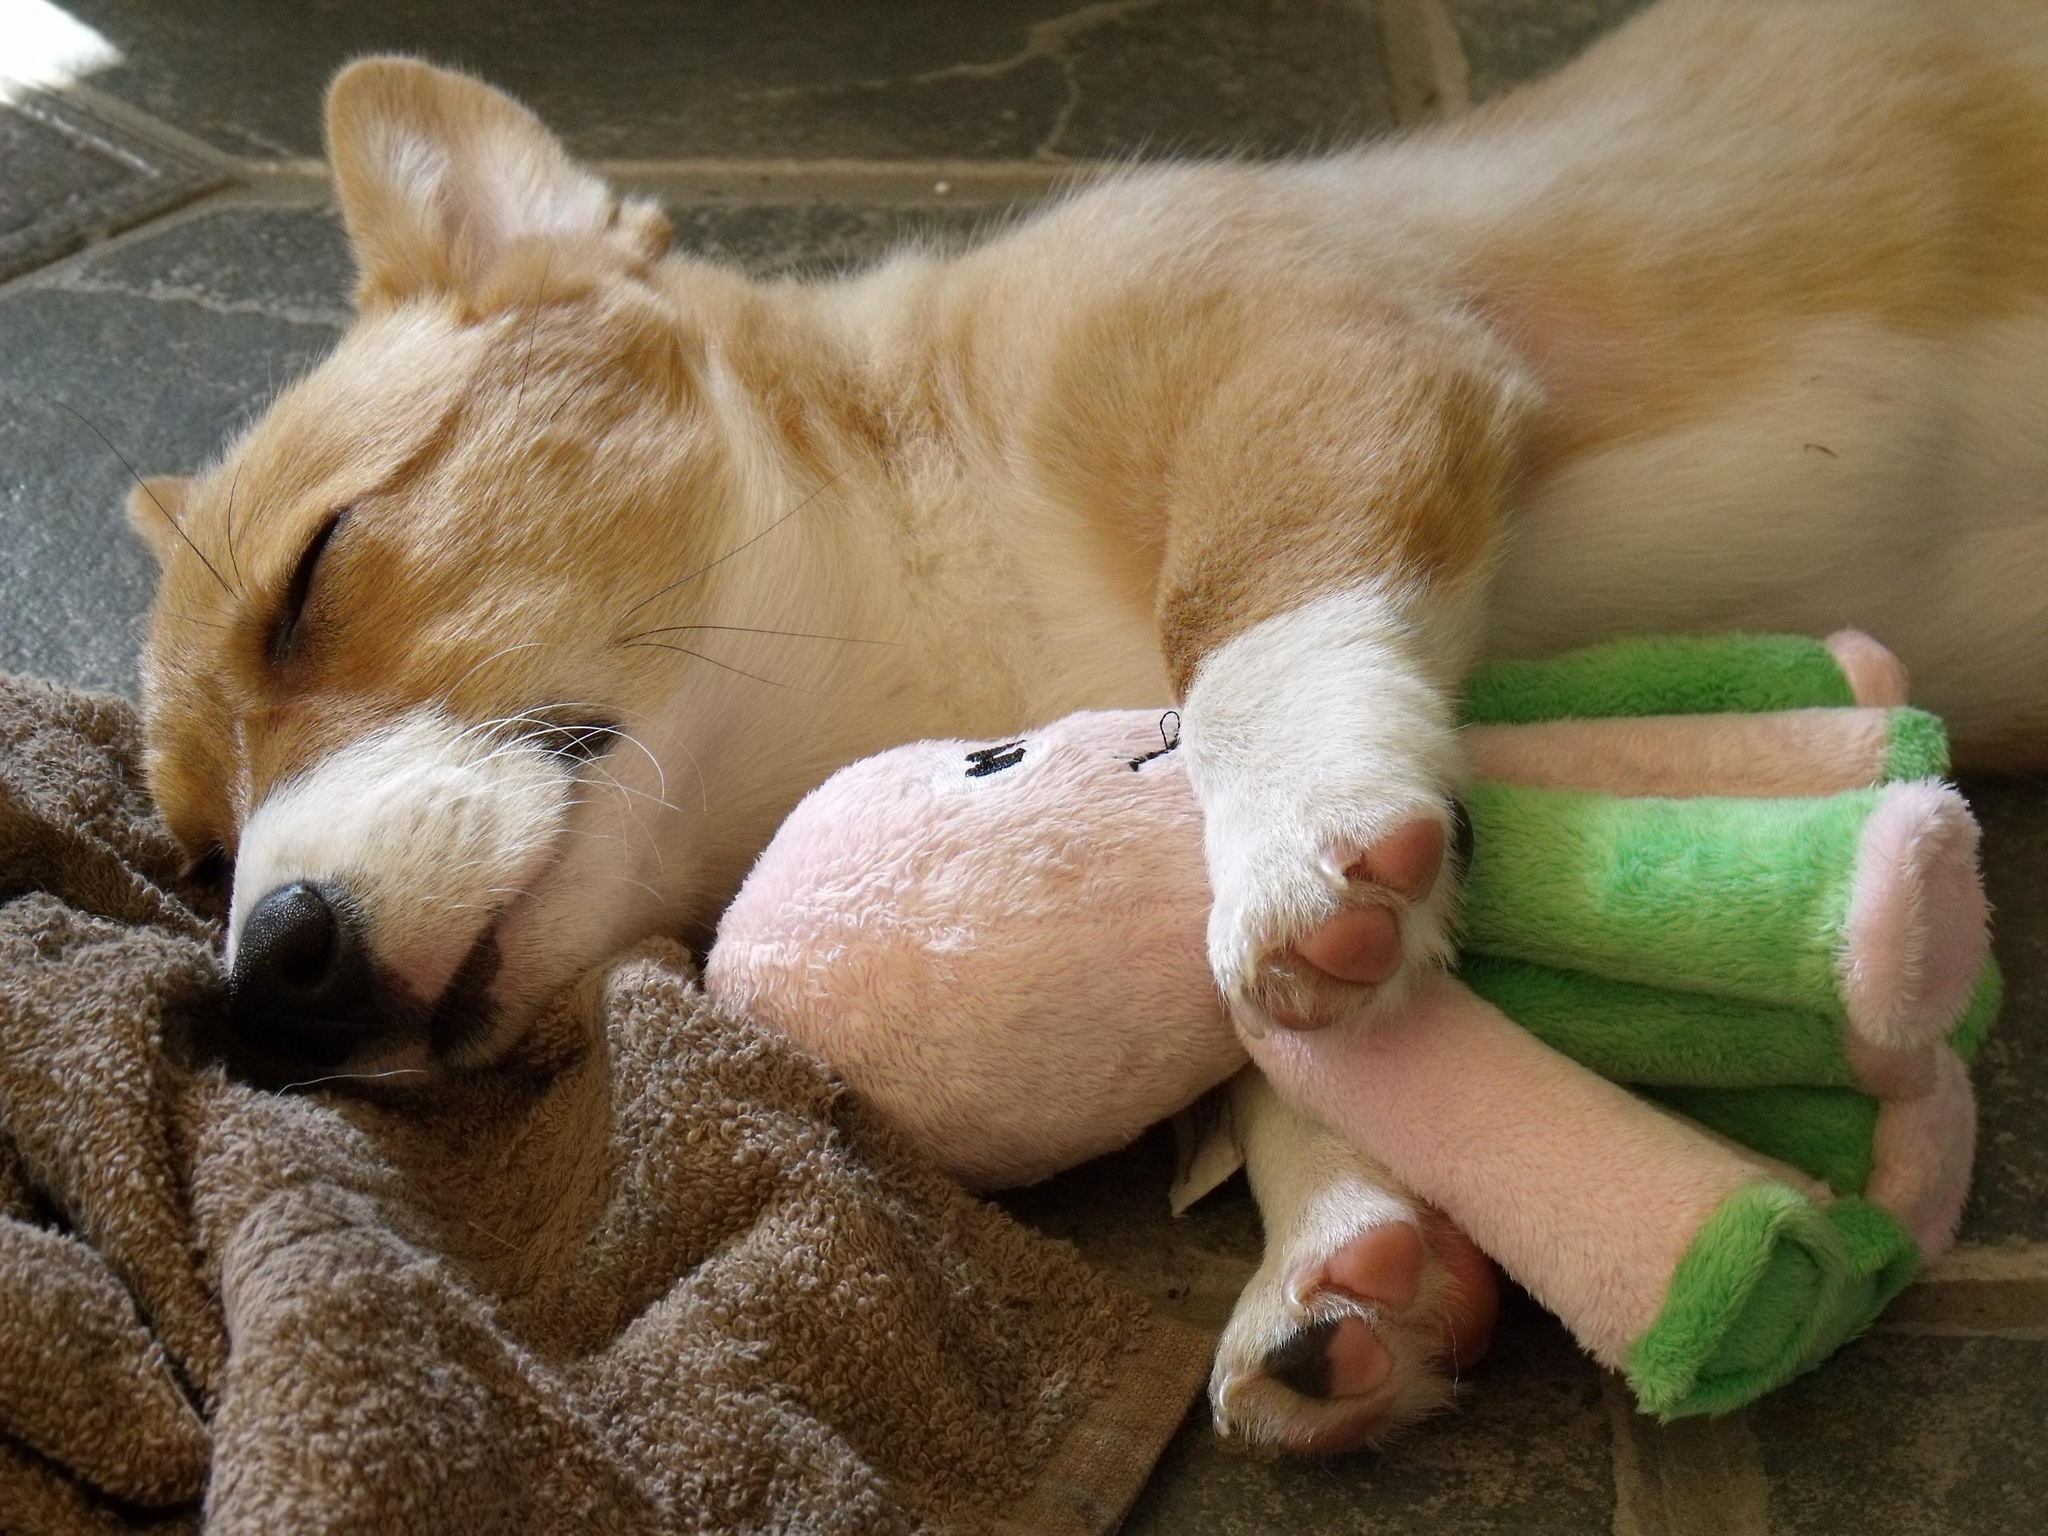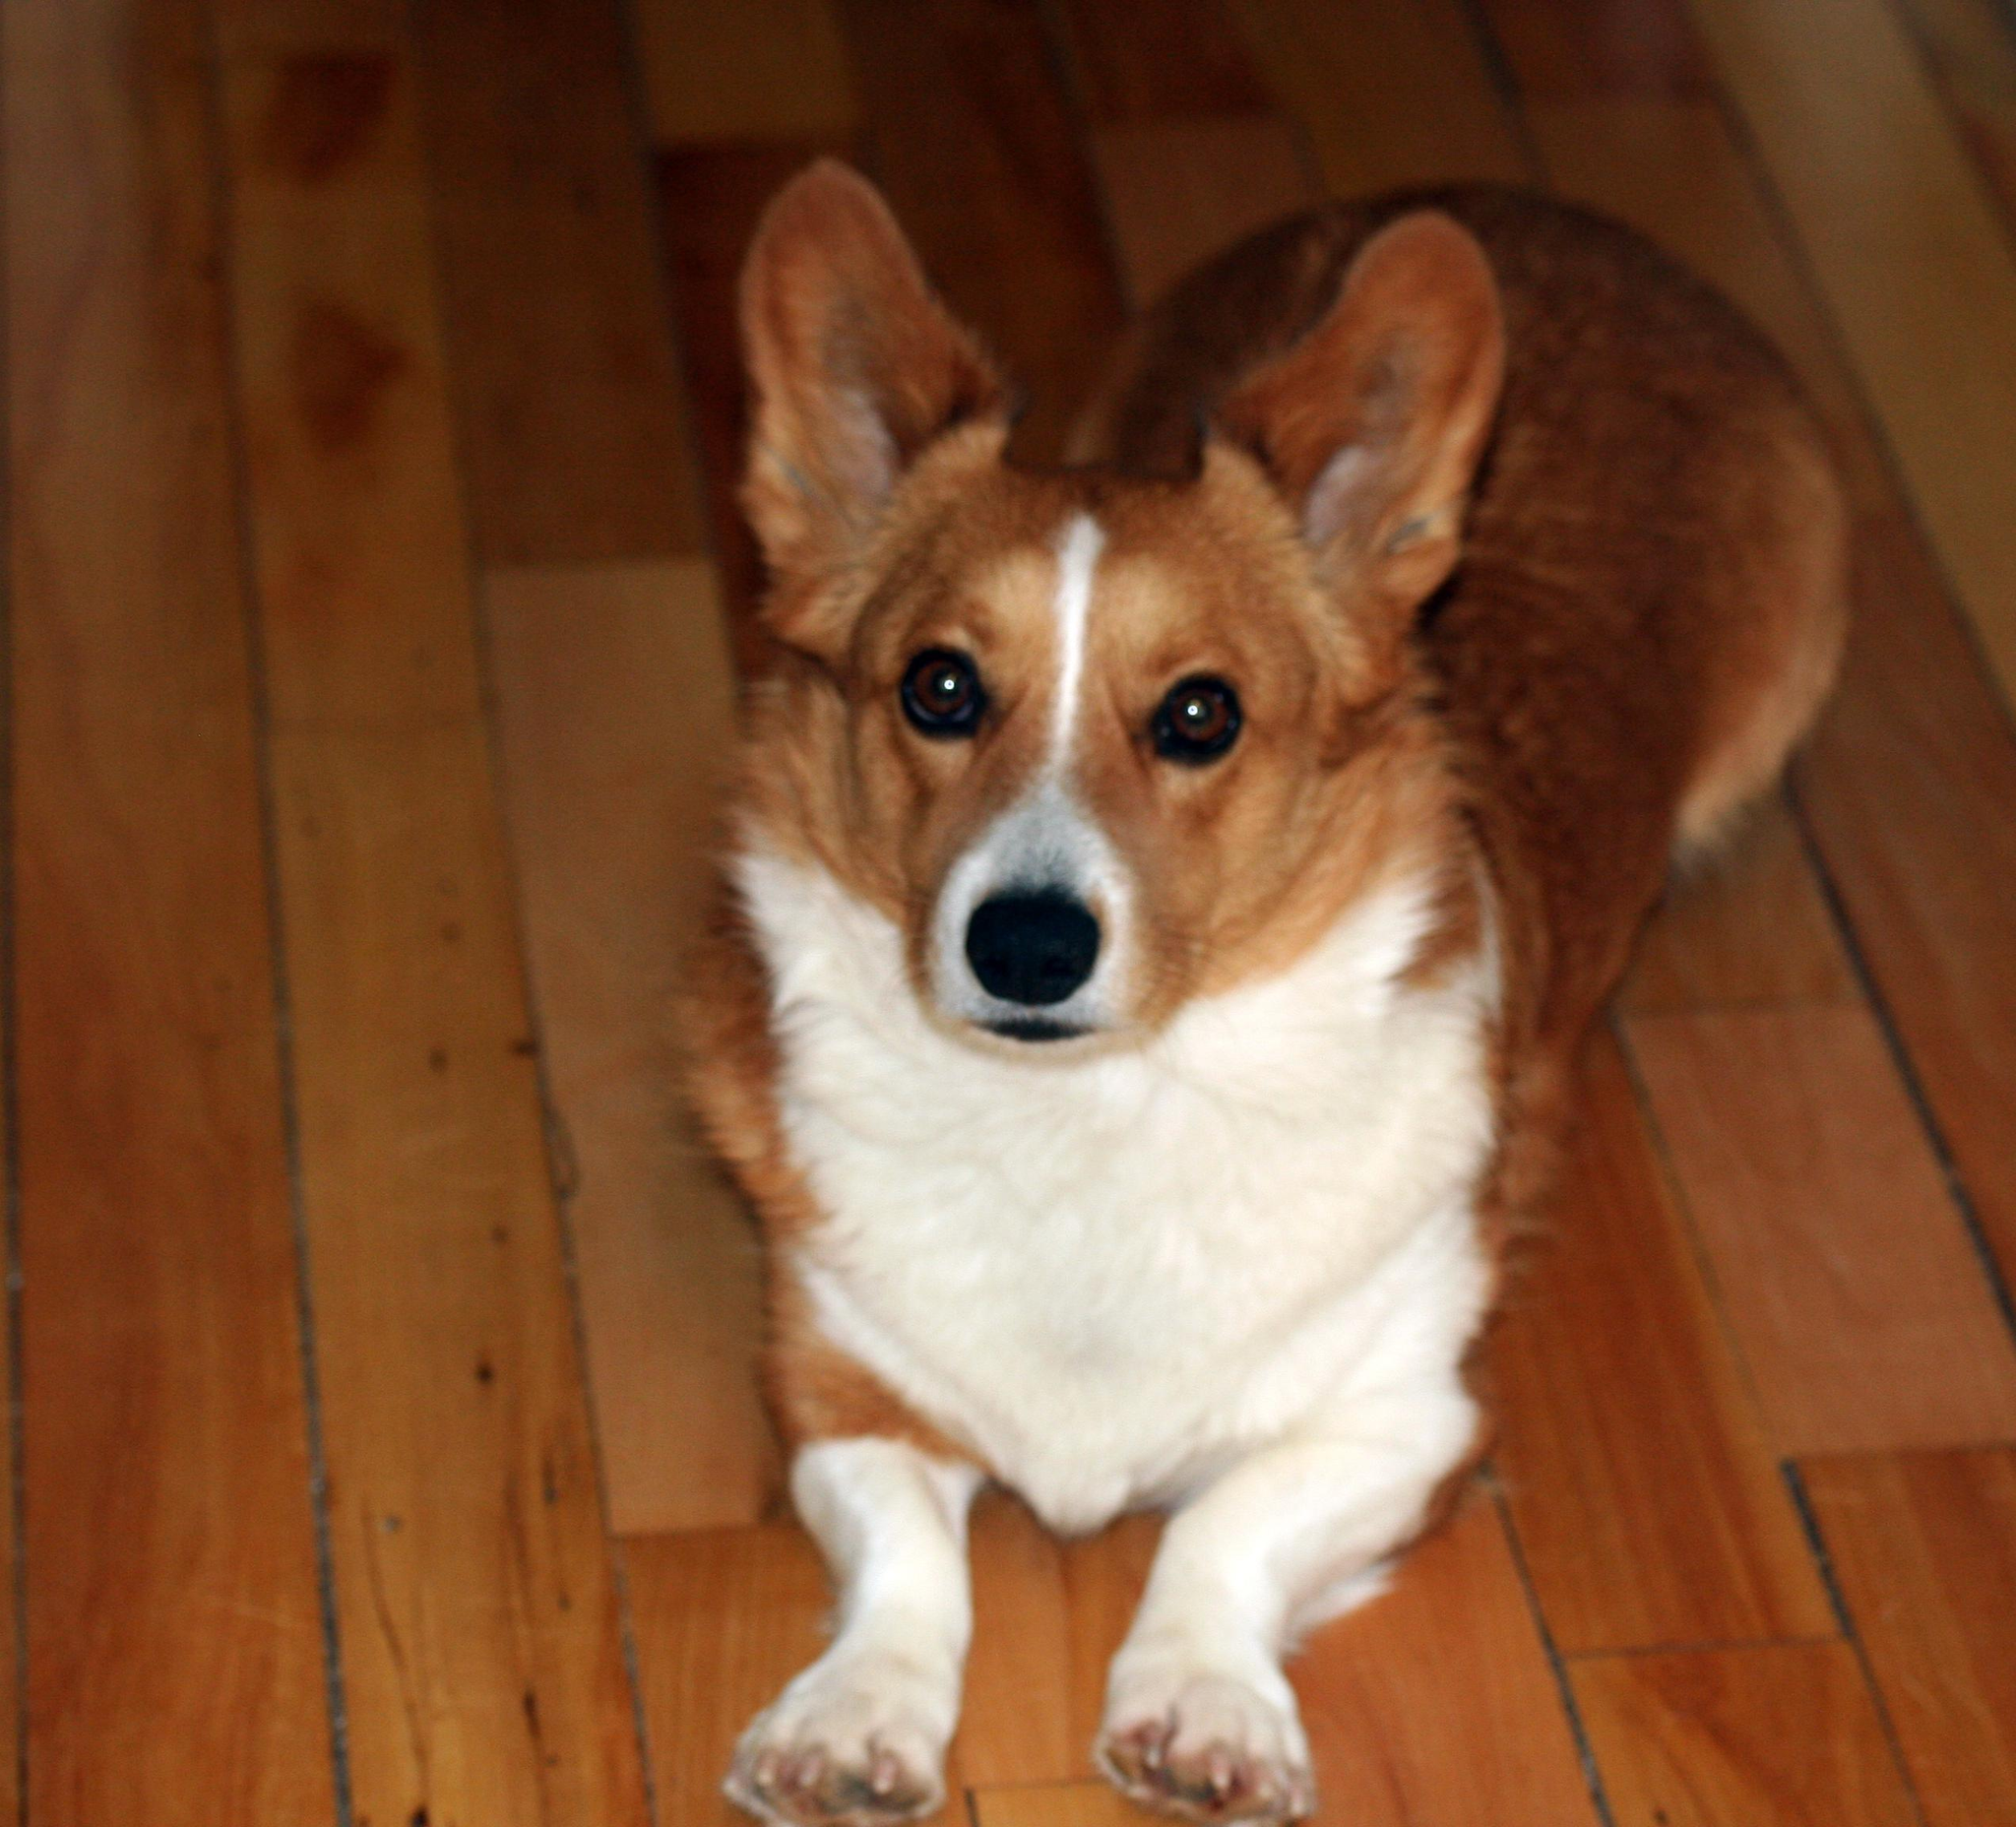The first image is the image on the left, the second image is the image on the right. Examine the images to the left and right. Is the description "A dog is sleeping beside a stuffed toy." accurate? Answer yes or no. Yes. The first image is the image on the left, the second image is the image on the right. For the images shown, is this caption "One dog is sleeping with a stuffed animal." true? Answer yes or no. Yes. 